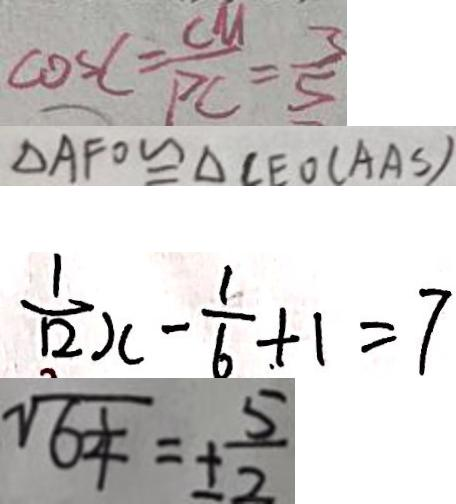<formula> <loc_0><loc_0><loc_500><loc_500>\cos C = \frac { C M } { P C } = \frac { 3 } { 5 } 
 \Delta A F O \cong \Delta C E O ( A A S ) 
 \frac { 1 } { 1 2 } x - \frac { 1 } { 6 } + 1 = 7 
 \sqrt { 6 \frac { 1 } { 4 } } = \pm \frac { 5 } { 2 }</formula> 